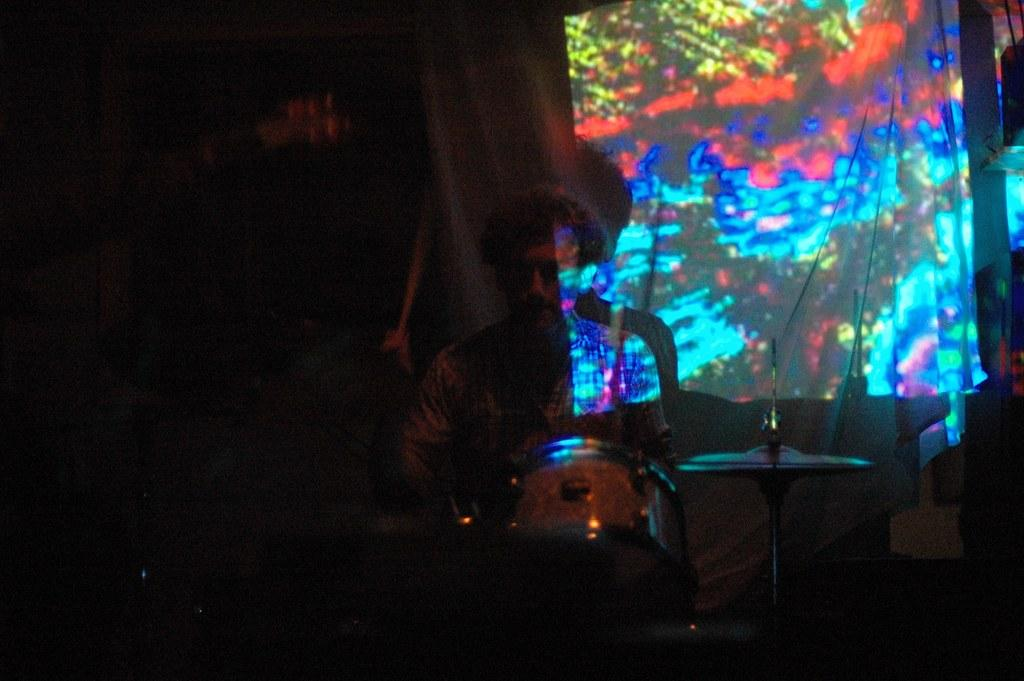What is the man in the image doing? The man is playing musical instruments in the image. What can be seen in the background of the image? There is a curtain and a light in the background of the image. How is the left side of the image different from the rest? The left side of the image is blurred. What type of shop can be seen in the background of the image? There is no shop visible in the background of the image; it only shows a curtain and a light. How does the man wash the musical instruments in the image? The image does not show the man washing the musical instruments; he is playing them. 